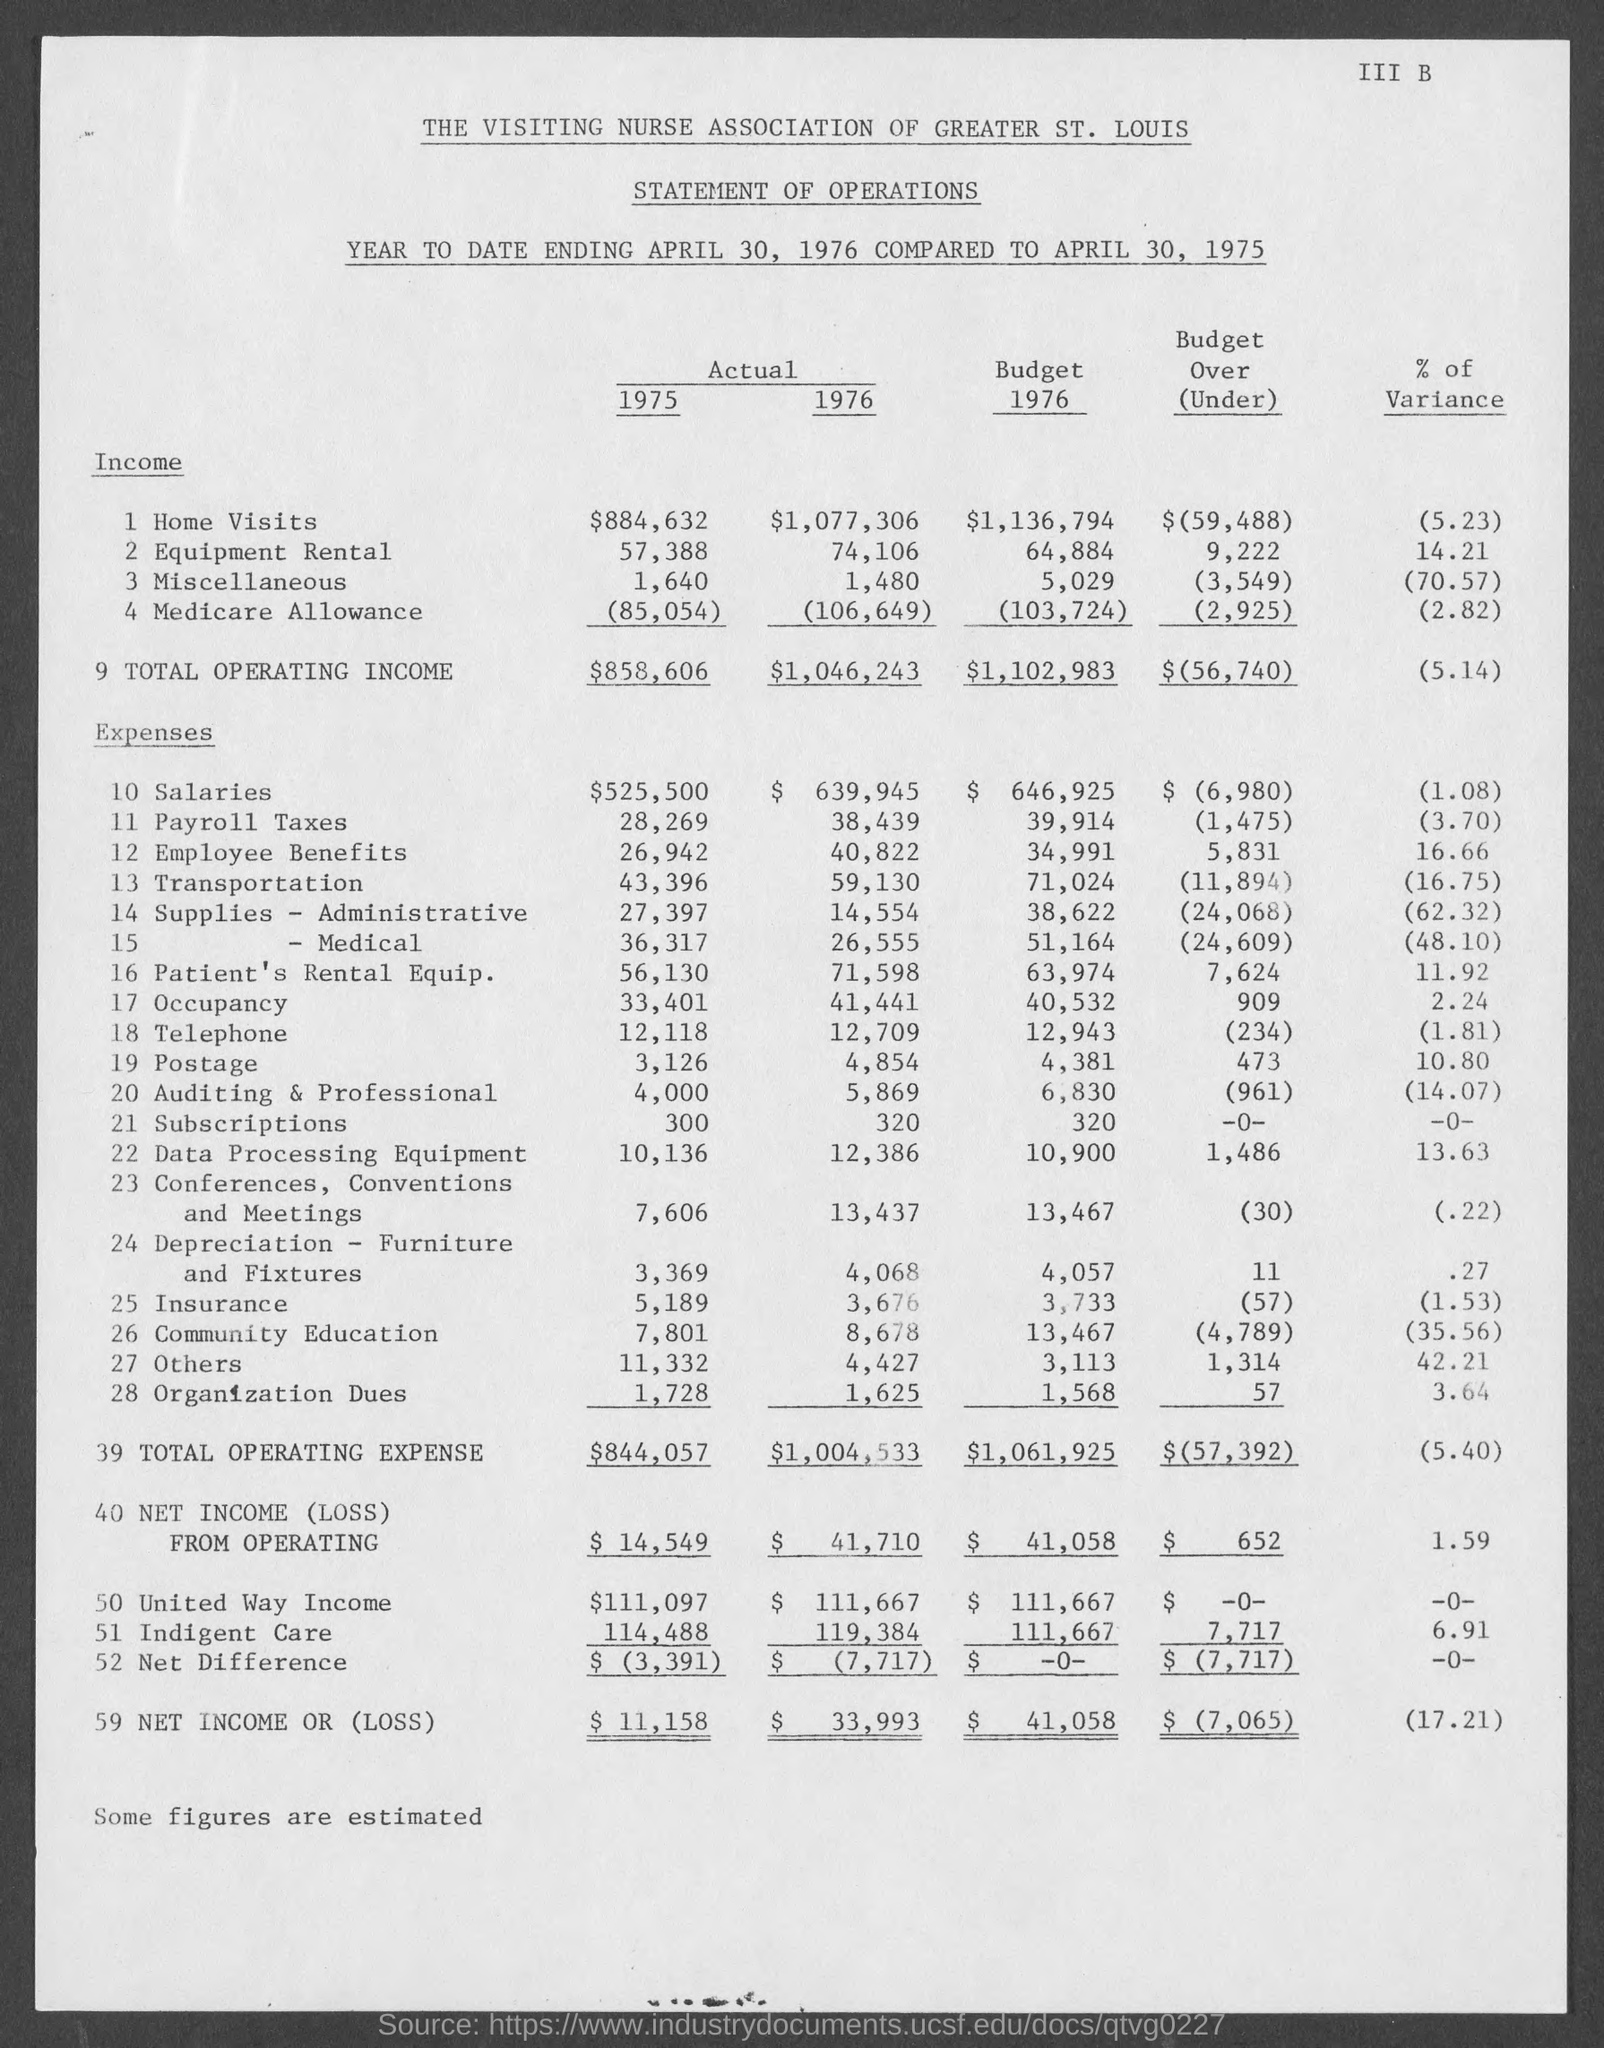What is the Actual Income for Home visits for 1975?
Your response must be concise. $884,632. What is the Actual Income for Home visits for 1976?
Ensure brevity in your answer.  $1,077,306. What is the Budget Income for Home visits for 1976?
Provide a short and direct response. $1,136,794. What is the Actual Income for Equipment Rental for 1975?
Provide a succinct answer. 57,388. What is the Actual Income for Equipment Rental for 1976?
Provide a succinct answer. 74,106. What is the Budget Income for Equipment Rental for 1976?
Give a very brief answer. 64,884. What is the Actual Income for Miscellaneous for 1975?
Offer a terse response. 1,640. What is the Actual Income for Miscellaneous for 1976?
Keep it short and to the point. 1,480. What is the Budget Income for Miscellaneous for 1976?
Make the answer very short. 5,029. What is the Actual Income for Medicare Allowance for 1975?
Provide a short and direct response. 85,054. 